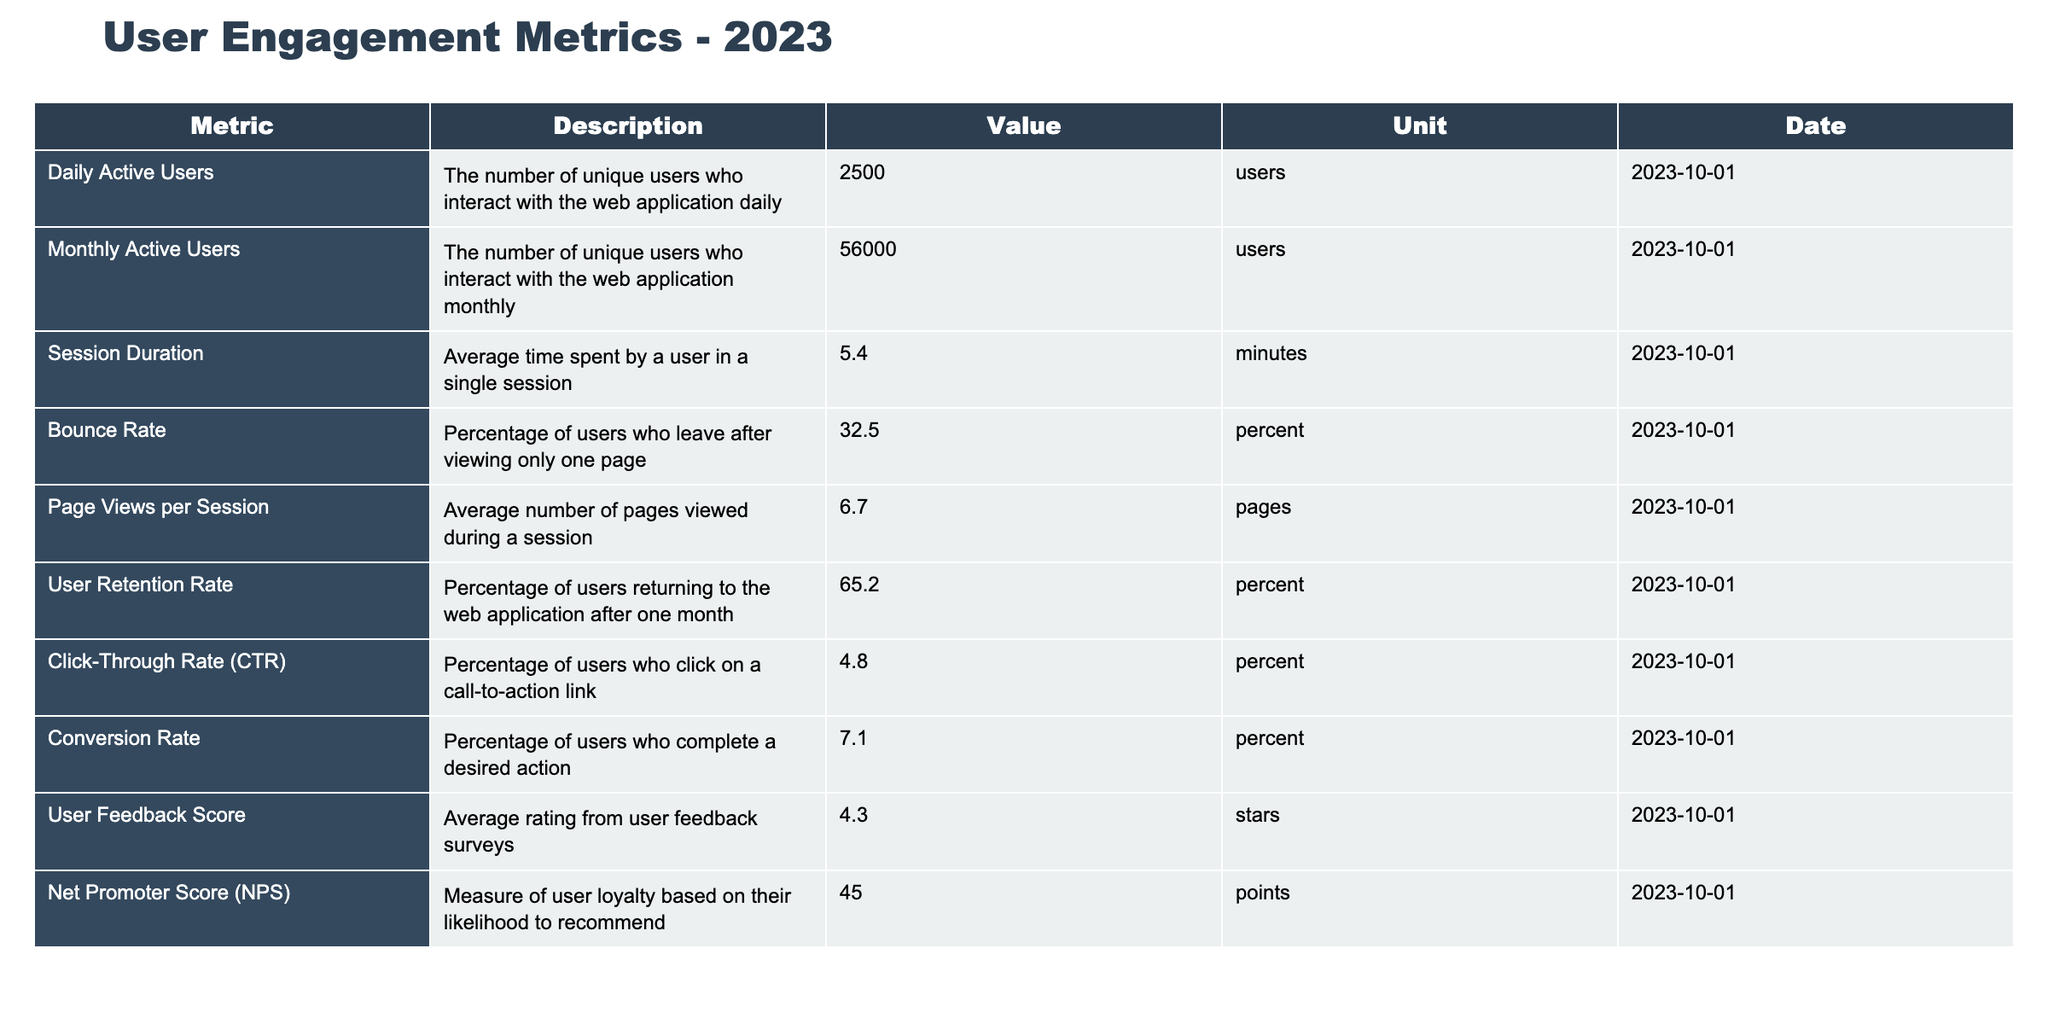What is the Daily Active Users count? The table shows the Daily Active Users metric, where the value is listed as 2500 users.
Answer: 2500 What is the Monthly Active Users value? According to the table, the Monthly Active Users metric is 56000 users.
Answer: 56000 What percentage of users leave after viewing only one page? The Bounce Rate in the table indicates that 32.5% of users leave after viewing just one page.
Answer: 32.5% What is the average Session Duration in minutes? The table lists the average Session Duration as 5.4 minutes.
Answer: 5.4 minutes How many Page Views per Session are there on average? According to the table, the average Page Views per Session is 6.7 pages.
Answer: 6.7 pages What is the User Retention Rate? The User Retention Rate given in the table is 65.2%.
Answer: 65.2% What is the Conversion Rate? The table specifies that the Conversion Rate is 7.1%.
Answer: 7.1% Is the Click-Through Rate (CTR) higher than 5%? The Click-Through Rate is listed as 4.8%, which is less than 5%, making the statement false.
Answer: No How does the User Feedback Score compare to 5 stars? The User Feedback Score in the table is 4.3 stars, which is below the maximum of 5, indicating lower satisfaction.
Answer: Below 5 stars If we compare the Daily Active Users to the Monthly Active Users, what is the ratio? The ratio of Daily Active Users (2500) to Monthly Active Users (56000) can be calculated as 2500/56000 = 0.0446, or about 4.46%.
Answer: 4.46% What is the difference between Monthly Active Users and Daily Active Users? The difference can be calculated as 56000 - 2500 = 53500 users.
Answer: 53500 What could be inferred about user engagement if the Net Promoter Score is 45? A Net Promoter Score of 45 typically indicates good user loyalty, meaning a considerable portion of users is likely to recommend the application.
Answer: Good user loyalty If the average Session Duration increased to 6.0 minutes, how would that change the Session Duration trend? An increase from 5.4 to 6.0 minutes would suggest users are spending more time engaging with the application, which is a positive trend for user engagement.
Answer: Positive trend for engagement 